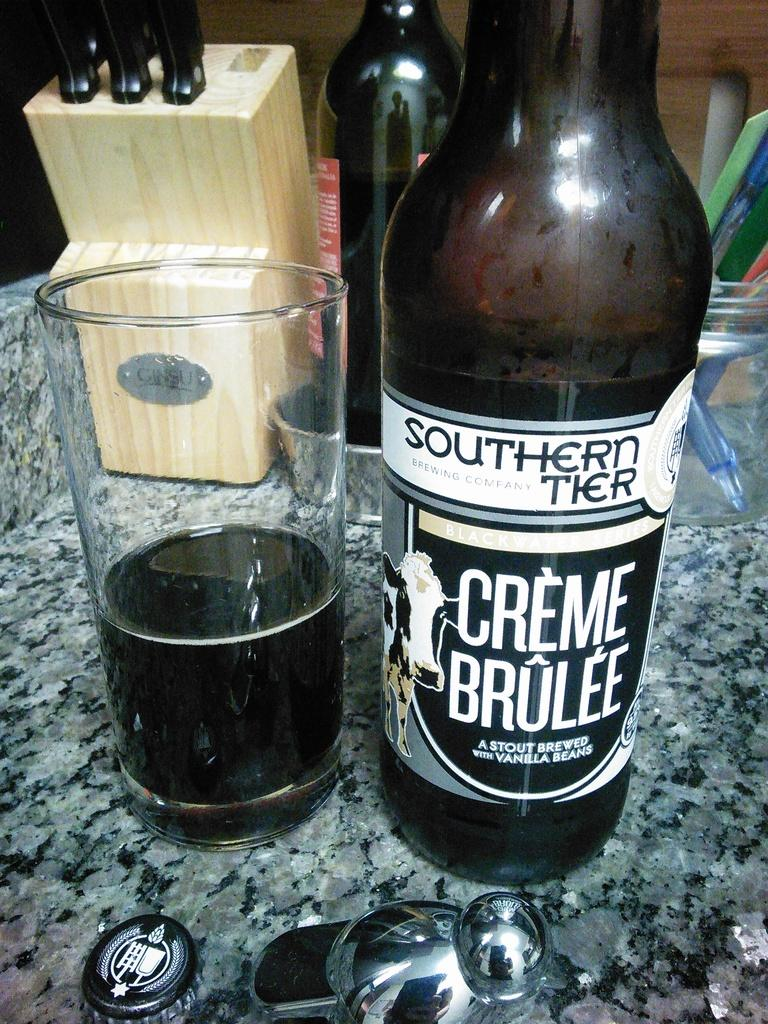What is the main piece of furniture in the image? There is a table in the image. What can be seen on the table? There is a glass with liquid, a bottle, a cap, a wooden box, a knife, and spoons on the table. What is the background of the table? The background of the table is a wall. How does the desire for help manifest itself in the image? There is no indication of desire or help in the image; it only shows a table with various objects on it. 